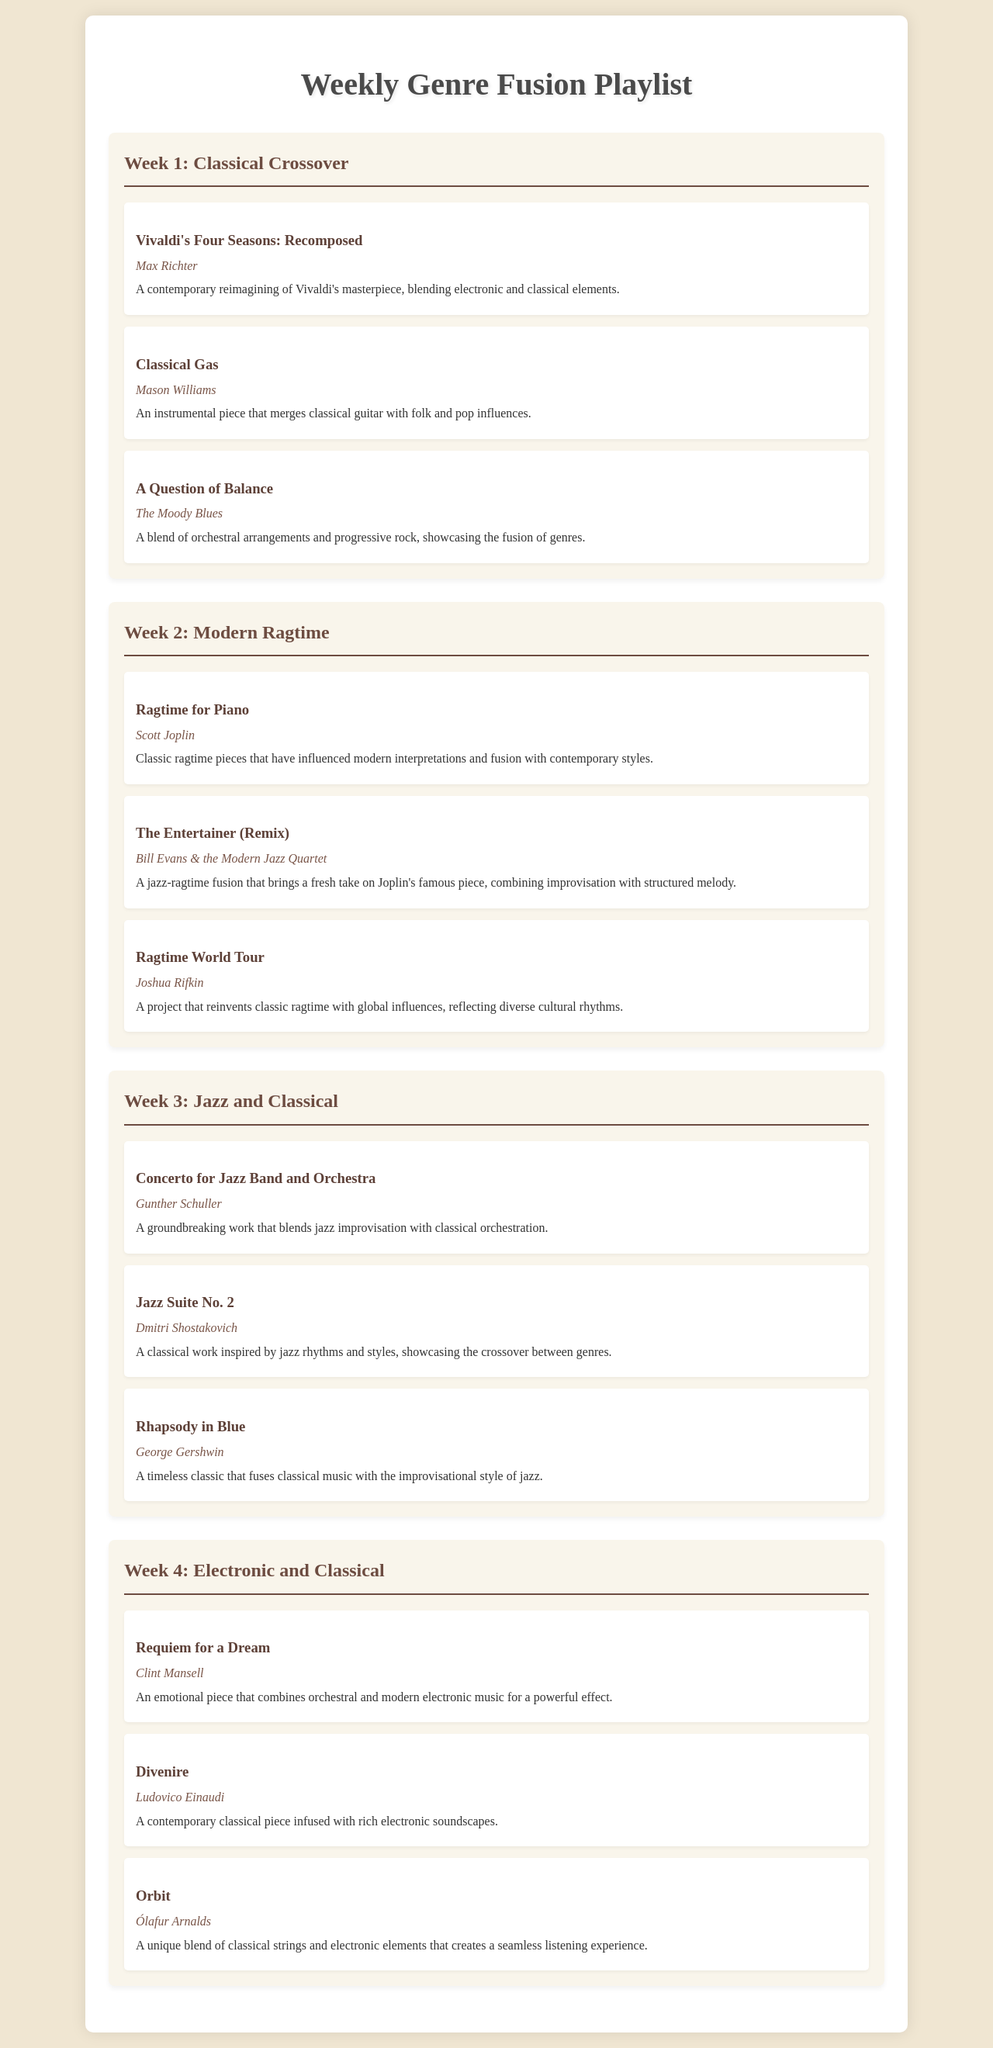What is the title of the playlist? The title of the playlist is provided at the top of the document as "Weekly Genre Fusion Playlist."
Answer: Weekly Genre Fusion Playlist Who is the artist of "Rhapsody in Blue"? The artist of "Rhapsody in Blue" is listed in the document under Week 3: Jazz and Classical.
Answer: George Gershwin What genre is explored in Week 1? The document specifies the theme of Week 1 by mentioning the genre in the heading.
Answer: Classical Crossover How many pieces are featured in Week 2? The number of pieces can be inferred from the highlighted sections within Week 2.
Answer: 3 Which artist is associated with "Requiem for a Dream"? The document lists the artist next to the respective piece in Week 4: Electronic and Classical.
Answer: Clint Mansell What elements are combined in "Vivaldi's Four Seasons: Recomposed"? The description for this piece mentions specific musical elements that are blended together.
Answer: Electronic and classical elements Which week features the "Concerto for Jazz Band and Orchestra"? The week is identified by the title provided in the document, which indicates the theme of that week.
Answer: Week 3 Which piece is described as a "jazz-ragtime fusion"? The description in Week 2 explicitly mentions the fusion genre as it relates to this specific piece.
Answer: The Entertainer (Remix) What is the focus of Week 4 in the playlist? The focus is determined by the title outlined for the week in the document.
Answer: Electronic and Classical 